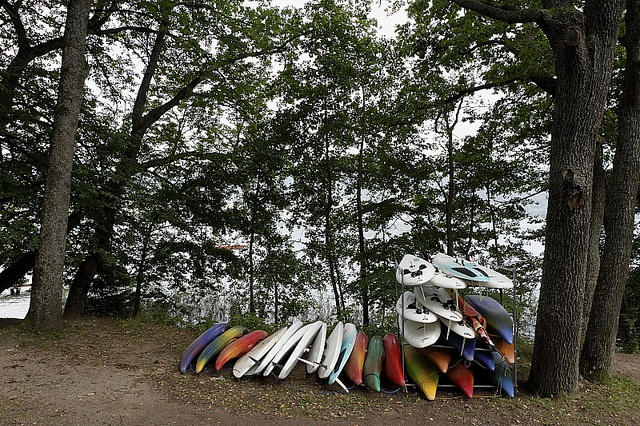Describe the objects in this image and their specific colors. I can see surfboard in black, lightgray, darkgray, and gray tones, surfboard in black and olive tones, surfboard in black, gray, lightgray, and darkgray tones, surfboard in black, lightgray, darkgray, and lightblue tones, and surfboard in black, lightgray, darkgray, and gray tones in this image. 